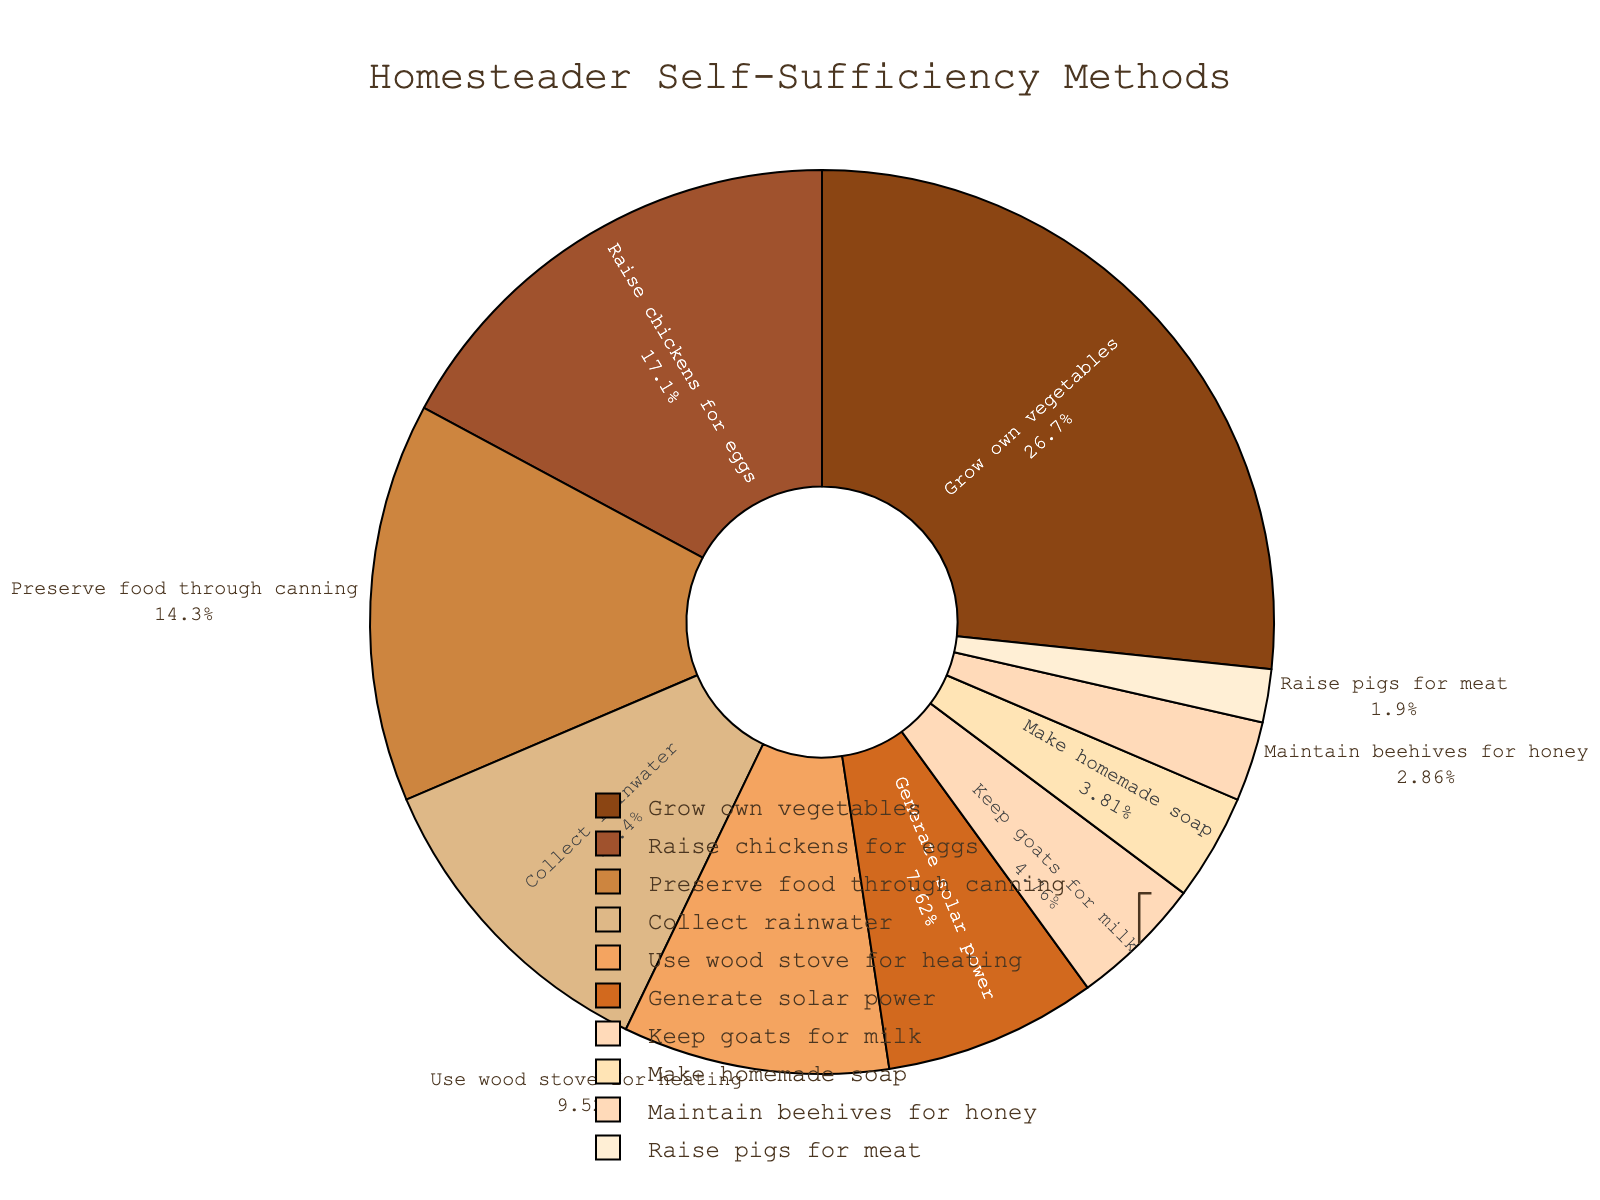Which self-sufficiency method is used by the highest percentage of homesteaders? The slice representing "Grow own vegetables" is the largest on the pie chart, and its percentage is 28%.
Answer: Grow own vegetables What is the total percentage of homesteaders who either raise chickens for eggs or keep goats for milk? The percentages for "Raise chickens for eggs" and "Keep goats for milk" are 18% and 5%, respectively. Adding these together gives 18% + 5% = 23%.
Answer: 23% Which method is used less frequently: generating solar power or making homemade soap? The percentage for "Generate solar power" is 8%, and for "Make homemade soap" is 4%. Since 4% < 8%, making homemade soap is used less frequently.
Answer: Make homemade soap How much more likely are homesteaders to grow their own vegetables compared to maintaining beehives for honey? The percentage for "Grow own vegetables" is 28%, and for "Maintain beehives for honey" is 3%. Subtracting these gives 28% - 3% = 25%.
Answer: 25% more likely What's the combined percentage of homesteaders who either use wood stoves for heating, generate solar power, or raise pigs for meat? The percentages for "Use wood stove for heating," "Generate solar power," and "Raise pigs for meat" are 10%, 8%, and 2%, respectively. Adding these together gives 10% + 8% + 2% = 20%.
Answer: 20% Which method has a percentage closest to 10% but not exceeding it? The methods shown are "Use wood stove for heating" with 10%, "Raise chickens for eggs" with 18%, and "Preserve food through canning" with 15%. The closest one to 10% without exceeding it is "Use wood stove for heating."
Answer: Use wood stove for heating If homesteaders practicing "Preserve food through canning" decided to also "Collect rainwater," what will their new combined percentage be? The percentages for "Preserve food through canning" and "Collect rainwater" are 15% and 12%, respectively. Adding these gives 15% + 12% = 27%.
Answer: 27% Among the least used methods, with 5% or less, which one has the highest percentage? The methods with 5% or less are "Keep goats for milk" (5%), "Make homemade soap" (4%), "Maintain beehives for honey" (3%), and "Raise pigs for meat" (2%). The highest percentage among these is "Keep goats for milk" with 5%.
Answer: Keep goats for milk How much more frequent is "Grow own vegetables" compared to all other methods combined? "Grow own vegetables" accounts for 28%. The sum of all other percentages is 18% + 15% + 12% + 10% + 8% + 5% + 4% + 3% + 2% = 77%. The difference is 77% - 28% = 49%.
Answer: 49% more frequent 